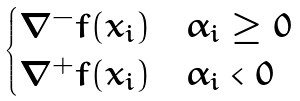<formula> <loc_0><loc_0><loc_500><loc_500>\begin{cases} \nabla ^ { - } f ( x _ { i } ) & \alpha _ { i } \geq 0 \\ \nabla ^ { + } f ( x _ { i } ) & \alpha _ { i } < 0 \end{cases}</formula> 